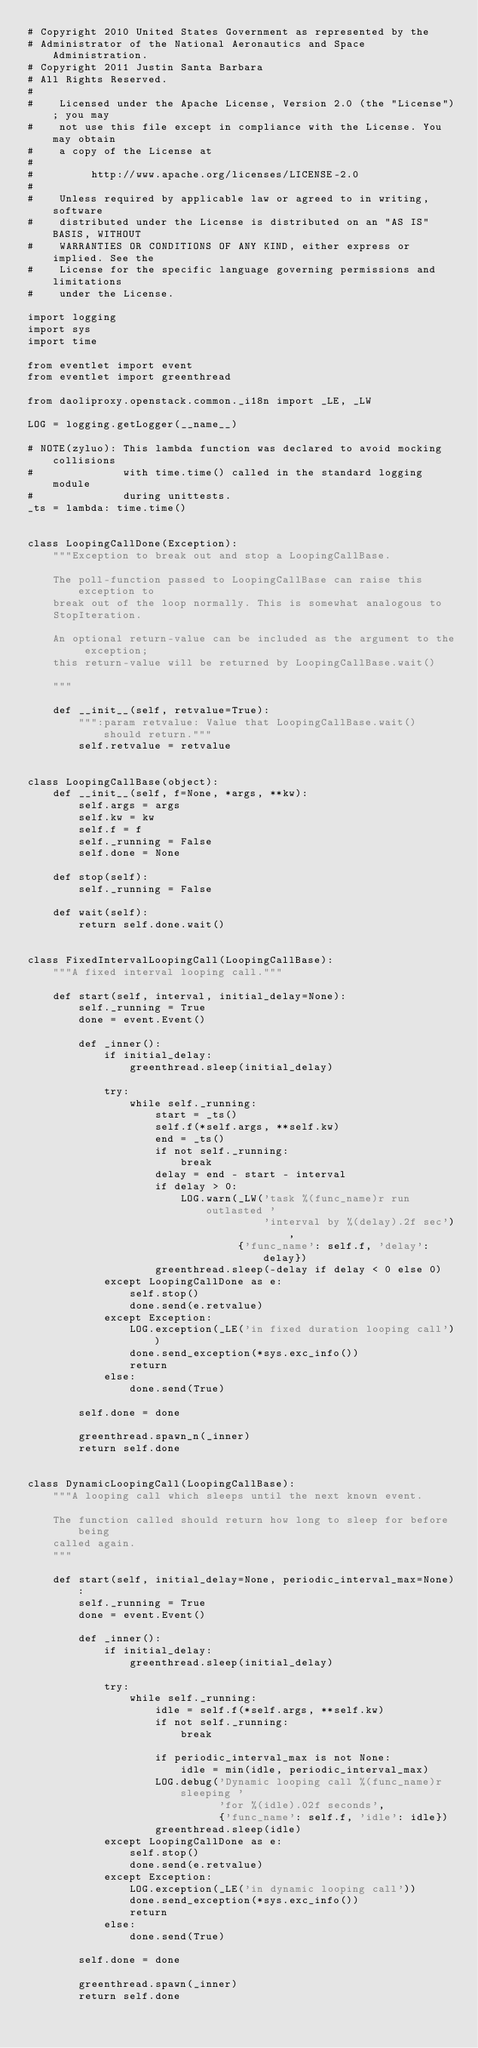<code> <loc_0><loc_0><loc_500><loc_500><_Python_># Copyright 2010 United States Government as represented by the
# Administrator of the National Aeronautics and Space Administration.
# Copyright 2011 Justin Santa Barbara
# All Rights Reserved.
#
#    Licensed under the Apache License, Version 2.0 (the "License"); you may
#    not use this file except in compliance with the License. You may obtain
#    a copy of the License at
#
#         http://www.apache.org/licenses/LICENSE-2.0
#
#    Unless required by applicable law or agreed to in writing, software
#    distributed under the License is distributed on an "AS IS" BASIS, WITHOUT
#    WARRANTIES OR CONDITIONS OF ANY KIND, either express or implied. See the
#    License for the specific language governing permissions and limitations
#    under the License.

import logging
import sys
import time

from eventlet import event
from eventlet import greenthread

from daoliproxy.openstack.common._i18n import _LE, _LW

LOG = logging.getLogger(__name__)

# NOTE(zyluo): This lambda function was declared to avoid mocking collisions
#              with time.time() called in the standard logging module
#              during unittests.
_ts = lambda: time.time()


class LoopingCallDone(Exception):
    """Exception to break out and stop a LoopingCallBase.

    The poll-function passed to LoopingCallBase can raise this exception to
    break out of the loop normally. This is somewhat analogous to
    StopIteration.

    An optional return-value can be included as the argument to the exception;
    this return-value will be returned by LoopingCallBase.wait()

    """

    def __init__(self, retvalue=True):
        """:param retvalue: Value that LoopingCallBase.wait() should return."""
        self.retvalue = retvalue


class LoopingCallBase(object):
    def __init__(self, f=None, *args, **kw):
        self.args = args
        self.kw = kw
        self.f = f
        self._running = False
        self.done = None

    def stop(self):
        self._running = False

    def wait(self):
        return self.done.wait()


class FixedIntervalLoopingCall(LoopingCallBase):
    """A fixed interval looping call."""

    def start(self, interval, initial_delay=None):
        self._running = True
        done = event.Event()

        def _inner():
            if initial_delay:
                greenthread.sleep(initial_delay)

            try:
                while self._running:
                    start = _ts()
                    self.f(*self.args, **self.kw)
                    end = _ts()
                    if not self._running:
                        break
                    delay = end - start - interval
                    if delay > 0:
                        LOG.warn(_LW('task %(func_name)r run outlasted '
                                     'interval by %(delay).2f sec'),
                                 {'func_name': self.f, 'delay': delay})
                    greenthread.sleep(-delay if delay < 0 else 0)
            except LoopingCallDone as e:
                self.stop()
                done.send(e.retvalue)
            except Exception:
                LOG.exception(_LE('in fixed duration looping call'))
                done.send_exception(*sys.exc_info())
                return
            else:
                done.send(True)

        self.done = done

        greenthread.spawn_n(_inner)
        return self.done


class DynamicLoopingCall(LoopingCallBase):
    """A looping call which sleeps until the next known event.

    The function called should return how long to sleep for before being
    called again.
    """

    def start(self, initial_delay=None, periodic_interval_max=None):
        self._running = True
        done = event.Event()

        def _inner():
            if initial_delay:
                greenthread.sleep(initial_delay)

            try:
                while self._running:
                    idle = self.f(*self.args, **self.kw)
                    if not self._running:
                        break

                    if periodic_interval_max is not None:
                        idle = min(idle, periodic_interval_max)
                    LOG.debug('Dynamic looping call %(func_name)r sleeping '
                              'for %(idle).02f seconds',
                              {'func_name': self.f, 'idle': idle})
                    greenthread.sleep(idle)
            except LoopingCallDone as e:
                self.stop()
                done.send(e.retvalue)
            except Exception:
                LOG.exception(_LE('in dynamic looping call'))
                done.send_exception(*sys.exc_info())
                return
            else:
                done.send(True)

        self.done = done

        greenthread.spawn(_inner)
        return self.done
</code> 